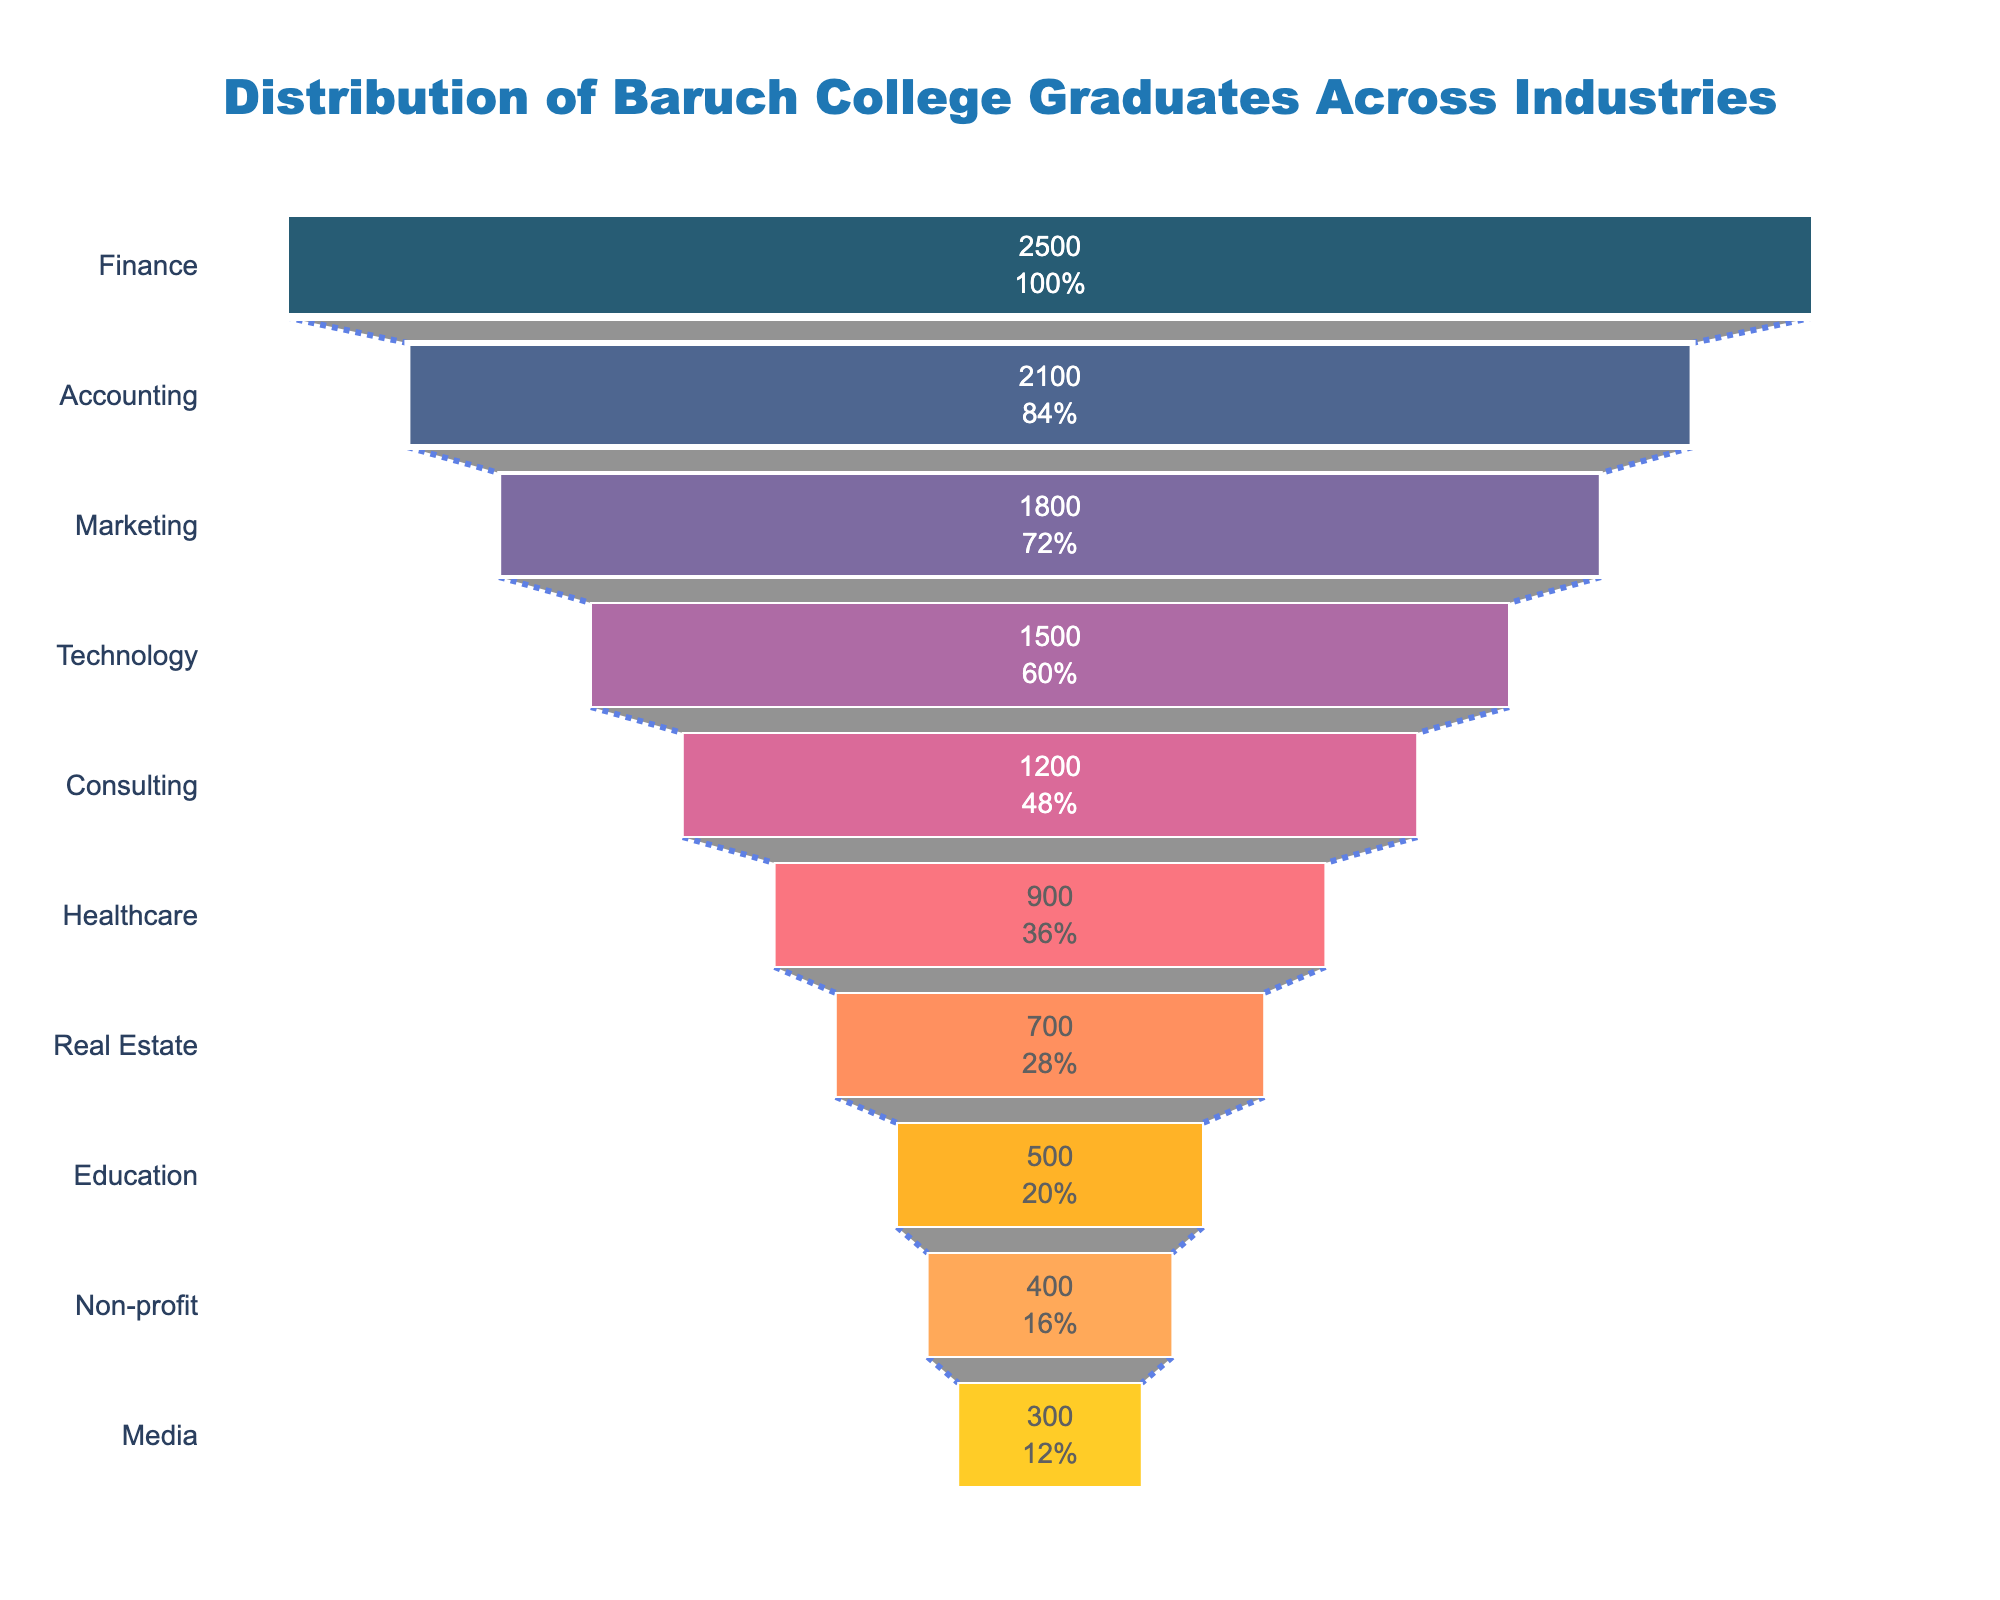what is the most popular industry among Baruch College graduates? By looking at the widest section at the top of the funnel chart, we can see that Finance is positioned at the top with the largest segment.
Answer: Finance How many industries have fewer than 1000 graduates? Count the sections of the funnel chart where the number of graduates is less than 1000. We see that Healthcare, Real Estate, Education, Non-profit, and Media fit this criteria.
Answer: 5 Which industry has the fewest graduates? By observing the narrowest section at the bottom of the funnel chart, we see that Media has the smallest segment.
Answer: Media What is the total number of graduates from Finance, Marketing, and Technology combined? Add the number of graduates from each of these industries: Finance (2500), Marketing (1800), and Technology (1500). The total is 2500 + 1800 + 1500 = 5800.
Answer: 5800 How many more graduates does Finance have compared to Accounting? Subtract the number of graduates in Accounting from the number in Finance: 2500 (Finance) - 2100 (Accounting) = 400.
Answer: 400 How does the percentage of total graduates in Finance compare to those in Healthcare? Calculate the percentage of total graduates for both industries and compare. Finance: 2500 / 12900 ≈ 19.4%, Healthcare: 900 / 12900 ≈ 7%.
Answer: Finance (19.4%) is higher than Healthcare (7%) If you combine the number of graduates in Consulting and Real Estate, where would this combined value rank in terms of popularity? Add the number of graduates in Consulting (1200) and Real Estate (700) to get 1900. Rank this combined value compared to individual industries. It would rank higher than Marketing (1800) but below Accounting (2100), making it the 3rd most popular.
Answer: 3rd What is the median number of graduates across all the industries? Arrange the number of graduates in ascending order and find the middle value. The ordered values are: 300, 400, 500, 700, 900, 1200, 1500, 1800, 2100, 2500. The median is the average of 900 and 1200, which is (900 + 1200) / 2 = 1050.
Answer: 1050 Which industry has around half the number of graduates as Technology? Technology has 1500 graduates, half of which is 1500 / 2 = 750. Real Estate, with 700 graduates, is the closest to this value.
Answer: Real Estate Are there more graduates in the top three industries combined than the rest combined? Sum the number of graduates for the top three industries (Finance: 2500, Accounting: 2100, Marketing: 1800) and compare with the sum for the remaining industries. Top three sum: 6400; Remaining sum: 12900 - 6400 = 6500. 6400 (top three) is less than 6500 (remaining).
Answer: No 